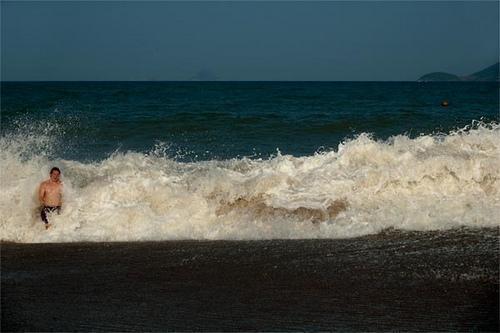How many people are there?
Give a very brief answer. 1. 